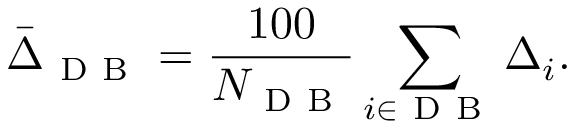<formula> <loc_0><loc_0><loc_500><loc_500>\bar { \Delta } _ { D B } = \frac { 1 0 0 } { N _ { D B } } \sum _ { i \in D B } \Delta _ { i } .</formula> 